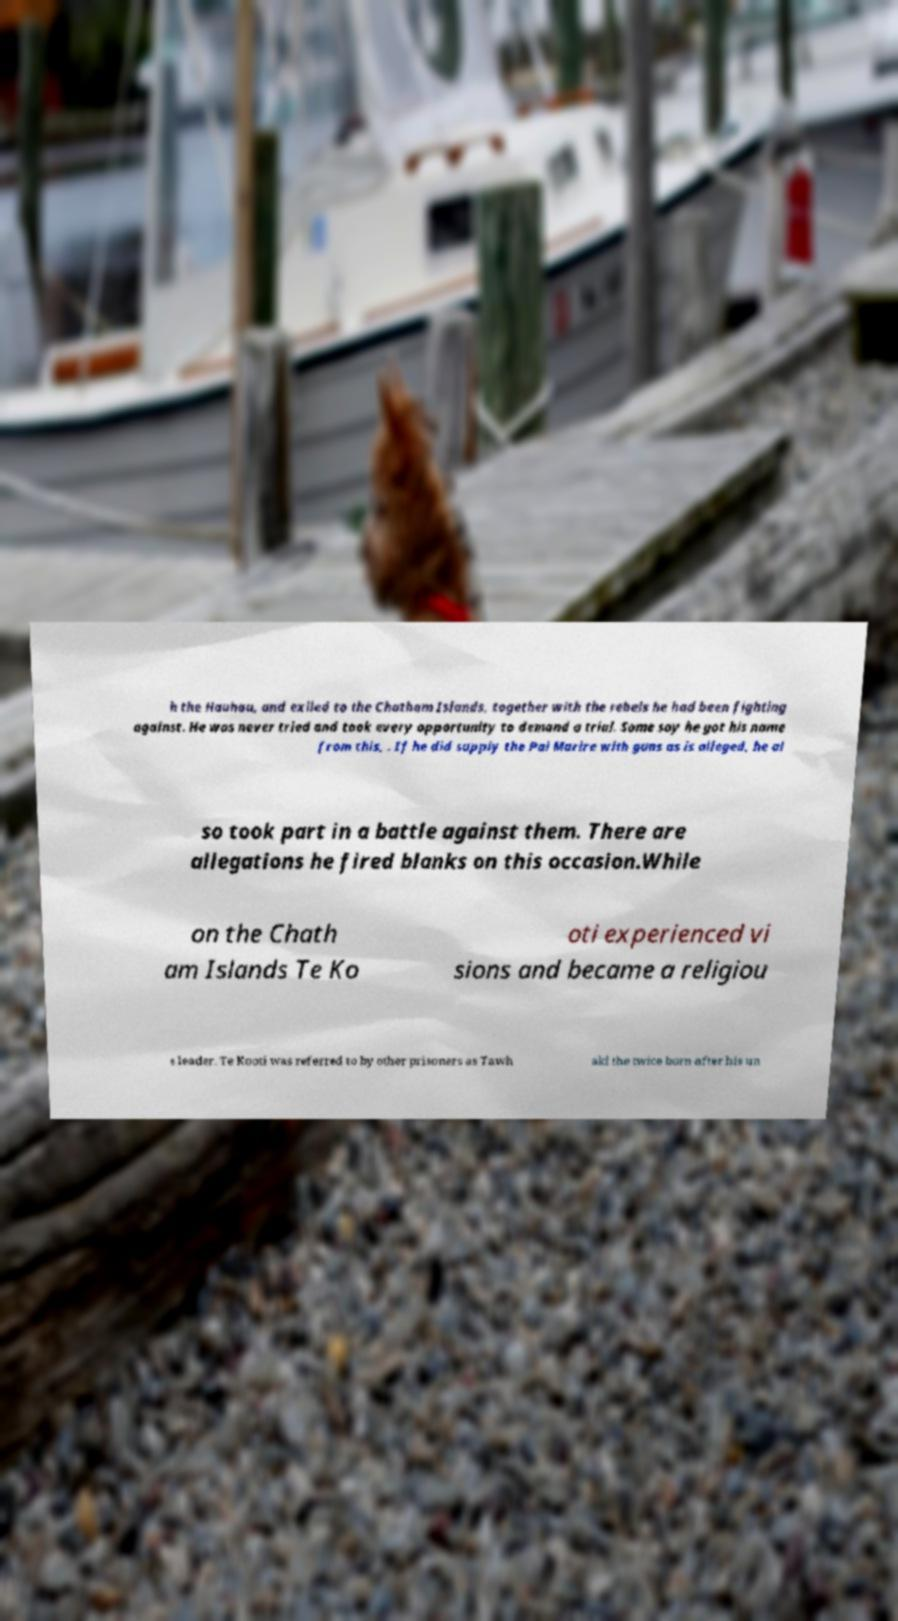Can you accurately transcribe the text from the provided image for me? h the Hauhau, and exiled to the Chatham Islands, together with the rebels he had been fighting against. He was never tried and took every opportunity to demand a trial. Some say he got his name from this, . If he did supply the Pai Marire with guns as is alleged, he al so took part in a battle against them. There are allegations he fired blanks on this occasion.While on the Chath am Islands Te Ko oti experienced vi sions and became a religiou s leader. Te Kooti was referred to by other prisoners as Tawh aki the twice born after his un 